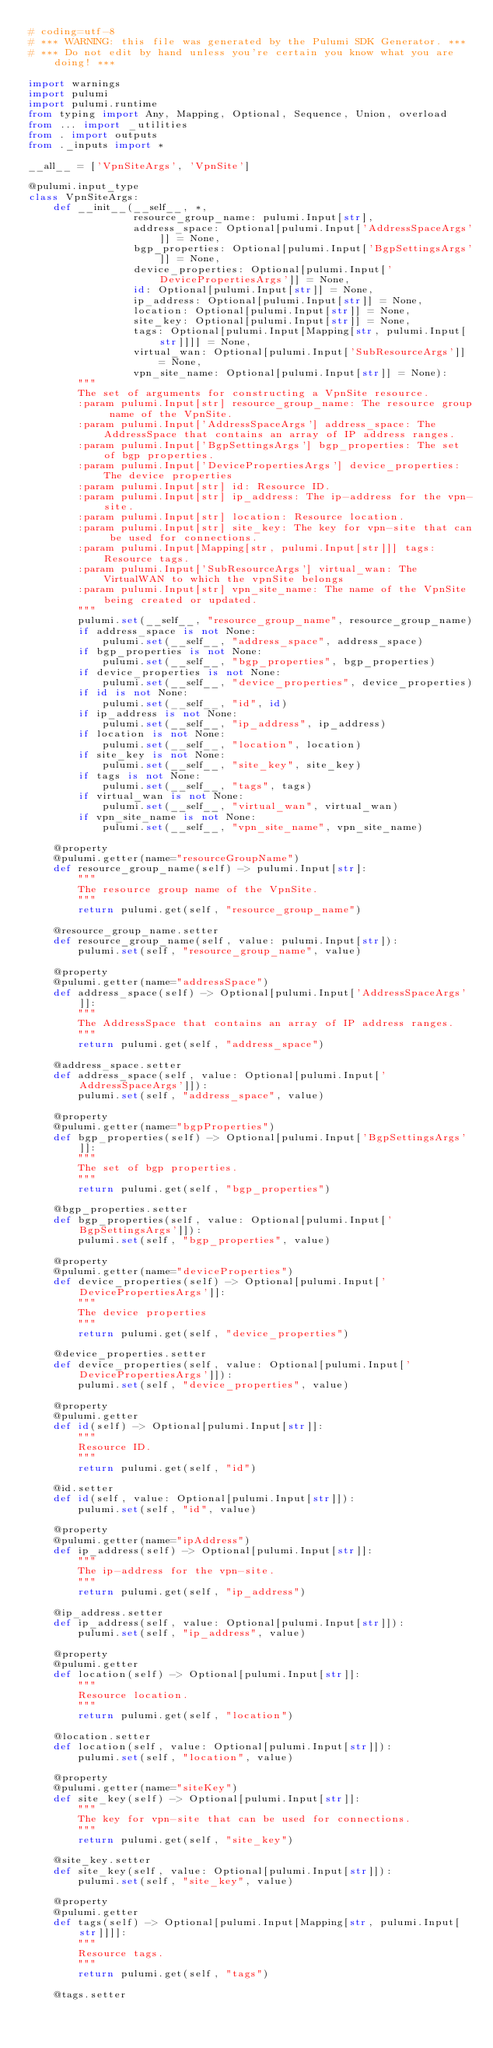Convert code to text. <code><loc_0><loc_0><loc_500><loc_500><_Python_># coding=utf-8
# *** WARNING: this file was generated by the Pulumi SDK Generator. ***
# *** Do not edit by hand unless you're certain you know what you are doing! ***

import warnings
import pulumi
import pulumi.runtime
from typing import Any, Mapping, Optional, Sequence, Union, overload
from ... import _utilities
from . import outputs
from ._inputs import *

__all__ = ['VpnSiteArgs', 'VpnSite']

@pulumi.input_type
class VpnSiteArgs:
    def __init__(__self__, *,
                 resource_group_name: pulumi.Input[str],
                 address_space: Optional[pulumi.Input['AddressSpaceArgs']] = None,
                 bgp_properties: Optional[pulumi.Input['BgpSettingsArgs']] = None,
                 device_properties: Optional[pulumi.Input['DevicePropertiesArgs']] = None,
                 id: Optional[pulumi.Input[str]] = None,
                 ip_address: Optional[pulumi.Input[str]] = None,
                 location: Optional[pulumi.Input[str]] = None,
                 site_key: Optional[pulumi.Input[str]] = None,
                 tags: Optional[pulumi.Input[Mapping[str, pulumi.Input[str]]]] = None,
                 virtual_wan: Optional[pulumi.Input['SubResourceArgs']] = None,
                 vpn_site_name: Optional[pulumi.Input[str]] = None):
        """
        The set of arguments for constructing a VpnSite resource.
        :param pulumi.Input[str] resource_group_name: The resource group name of the VpnSite.
        :param pulumi.Input['AddressSpaceArgs'] address_space: The AddressSpace that contains an array of IP address ranges.
        :param pulumi.Input['BgpSettingsArgs'] bgp_properties: The set of bgp properties.
        :param pulumi.Input['DevicePropertiesArgs'] device_properties: The device properties
        :param pulumi.Input[str] id: Resource ID.
        :param pulumi.Input[str] ip_address: The ip-address for the vpn-site.
        :param pulumi.Input[str] location: Resource location.
        :param pulumi.Input[str] site_key: The key for vpn-site that can be used for connections.
        :param pulumi.Input[Mapping[str, pulumi.Input[str]]] tags: Resource tags.
        :param pulumi.Input['SubResourceArgs'] virtual_wan: The VirtualWAN to which the vpnSite belongs
        :param pulumi.Input[str] vpn_site_name: The name of the VpnSite being created or updated.
        """
        pulumi.set(__self__, "resource_group_name", resource_group_name)
        if address_space is not None:
            pulumi.set(__self__, "address_space", address_space)
        if bgp_properties is not None:
            pulumi.set(__self__, "bgp_properties", bgp_properties)
        if device_properties is not None:
            pulumi.set(__self__, "device_properties", device_properties)
        if id is not None:
            pulumi.set(__self__, "id", id)
        if ip_address is not None:
            pulumi.set(__self__, "ip_address", ip_address)
        if location is not None:
            pulumi.set(__self__, "location", location)
        if site_key is not None:
            pulumi.set(__self__, "site_key", site_key)
        if tags is not None:
            pulumi.set(__self__, "tags", tags)
        if virtual_wan is not None:
            pulumi.set(__self__, "virtual_wan", virtual_wan)
        if vpn_site_name is not None:
            pulumi.set(__self__, "vpn_site_name", vpn_site_name)

    @property
    @pulumi.getter(name="resourceGroupName")
    def resource_group_name(self) -> pulumi.Input[str]:
        """
        The resource group name of the VpnSite.
        """
        return pulumi.get(self, "resource_group_name")

    @resource_group_name.setter
    def resource_group_name(self, value: pulumi.Input[str]):
        pulumi.set(self, "resource_group_name", value)

    @property
    @pulumi.getter(name="addressSpace")
    def address_space(self) -> Optional[pulumi.Input['AddressSpaceArgs']]:
        """
        The AddressSpace that contains an array of IP address ranges.
        """
        return pulumi.get(self, "address_space")

    @address_space.setter
    def address_space(self, value: Optional[pulumi.Input['AddressSpaceArgs']]):
        pulumi.set(self, "address_space", value)

    @property
    @pulumi.getter(name="bgpProperties")
    def bgp_properties(self) -> Optional[pulumi.Input['BgpSettingsArgs']]:
        """
        The set of bgp properties.
        """
        return pulumi.get(self, "bgp_properties")

    @bgp_properties.setter
    def bgp_properties(self, value: Optional[pulumi.Input['BgpSettingsArgs']]):
        pulumi.set(self, "bgp_properties", value)

    @property
    @pulumi.getter(name="deviceProperties")
    def device_properties(self) -> Optional[pulumi.Input['DevicePropertiesArgs']]:
        """
        The device properties
        """
        return pulumi.get(self, "device_properties")

    @device_properties.setter
    def device_properties(self, value: Optional[pulumi.Input['DevicePropertiesArgs']]):
        pulumi.set(self, "device_properties", value)

    @property
    @pulumi.getter
    def id(self) -> Optional[pulumi.Input[str]]:
        """
        Resource ID.
        """
        return pulumi.get(self, "id")

    @id.setter
    def id(self, value: Optional[pulumi.Input[str]]):
        pulumi.set(self, "id", value)

    @property
    @pulumi.getter(name="ipAddress")
    def ip_address(self) -> Optional[pulumi.Input[str]]:
        """
        The ip-address for the vpn-site.
        """
        return pulumi.get(self, "ip_address")

    @ip_address.setter
    def ip_address(self, value: Optional[pulumi.Input[str]]):
        pulumi.set(self, "ip_address", value)

    @property
    @pulumi.getter
    def location(self) -> Optional[pulumi.Input[str]]:
        """
        Resource location.
        """
        return pulumi.get(self, "location")

    @location.setter
    def location(self, value: Optional[pulumi.Input[str]]):
        pulumi.set(self, "location", value)

    @property
    @pulumi.getter(name="siteKey")
    def site_key(self) -> Optional[pulumi.Input[str]]:
        """
        The key for vpn-site that can be used for connections.
        """
        return pulumi.get(self, "site_key")

    @site_key.setter
    def site_key(self, value: Optional[pulumi.Input[str]]):
        pulumi.set(self, "site_key", value)

    @property
    @pulumi.getter
    def tags(self) -> Optional[pulumi.Input[Mapping[str, pulumi.Input[str]]]]:
        """
        Resource tags.
        """
        return pulumi.get(self, "tags")

    @tags.setter</code> 